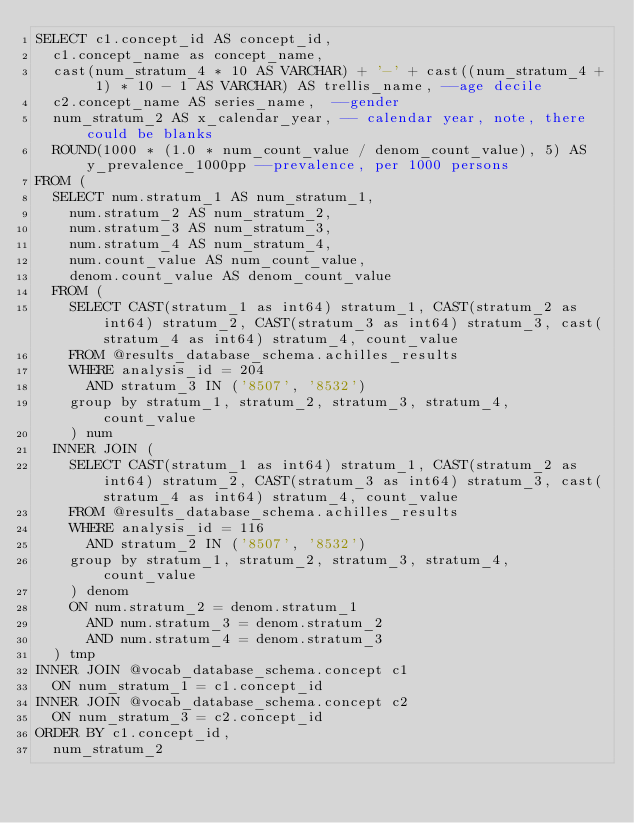<code> <loc_0><loc_0><loc_500><loc_500><_SQL_>SELECT c1.concept_id AS concept_id,
	c1.concept_name as concept_name,
  cast(num_stratum_4 * 10 AS VARCHAR) + '-' + cast((num_stratum_4 + 1) * 10 - 1 AS VARCHAR) AS trellis_name, --age decile
	c2.concept_name AS series_name,  --gender
	num_stratum_2 AS x_calendar_year, -- calendar year, note, there could be blanks
	ROUND(1000 * (1.0 * num_count_value / denom_count_value), 5) AS y_prevalence_1000pp --prevalence, per 1000 persons
FROM (
	SELECT num.stratum_1 AS num_stratum_1,
		num.stratum_2 AS num_stratum_2,
		num.stratum_3 AS num_stratum_3,
		num.stratum_4 AS num_stratum_4,
		num.count_value AS num_count_value,
		denom.count_value AS denom_count_value
	FROM (
    SELECT CAST(stratum_1 as int64) stratum_1, CAST(stratum_2 as int64) stratum_2, CAST(stratum_3 as int64) stratum_3, cast(stratum_4 as int64) stratum_4, count_value
		FROM @results_database_schema.achilles_results
		WHERE analysis_id = 204
			AND stratum_3 IN ('8507', '8532')
		group by stratum_1, stratum_2, stratum_3, stratum_4, count_value
		) num
	INNER JOIN (
    SELECT CAST(stratum_1 as int64) stratum_1, CAST(stratum_2 as int64) stratum_2, CAST(stratum_3 as int64) stratum_3, cast(stratum_4 as int64) stratum_4, count_value
		FROM @results_database_schema.achilles_results
		WHERE analysis_id = 116
			AND stratum_2 IN ('8507', '8532')
		group by stratum_1, stratum_2, stratum_3, stratum_4, count_value
		) denom
		ON num.stratum_2 = denom.stratum_1
			AND num.stratum_3 = denom.stratum_2
			AND num.stratum_4 = denom.stratum_3
	) tmp
INNER JOIN @vocab_database_schema.concept c1
	ON num_stratum_1 = c1.concept_id
INNER JOIN @vocab_database_schema.concept c2
	ON num_stratum_3 = c2.concept_id
ORDER BY c1.concept_id,
	num_stratum_2
</code> 